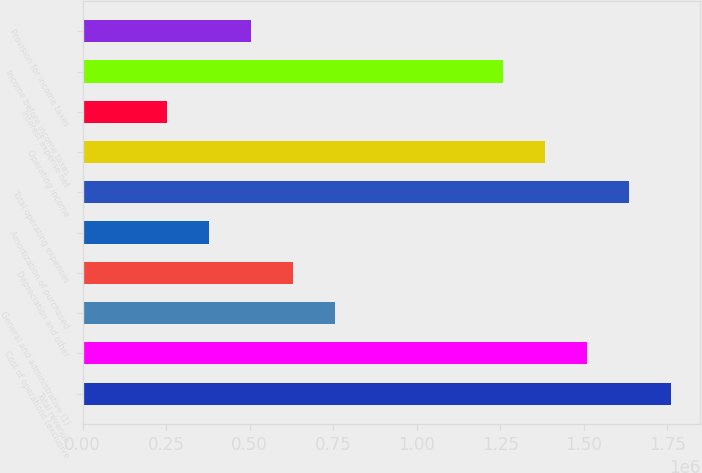Convert chart. <chart><loc_0><loc_0><loc_500><loc_500><bar_chart><fcel>Total revenue<fcel>Cost of operations (exclusive<fcel>General and administrative (1)<fcel>Depreciation and other<fcel>Amortization of purchased<fcel>Total operating expenses<fcel>Operating income<fcel>Interest expense net<fcel>Income before income taxes<fcel>Provision for income taxes<nl><fcel>1.76041e+06<fcel>1.50893e+06<fcel>754463<fcel>628720<fcel>377232<fcel>1.63467e+06<fcel>1.38318e+06<fcel>251489<fcel>1.25744e+06<fcel>502976<nl></chart> 